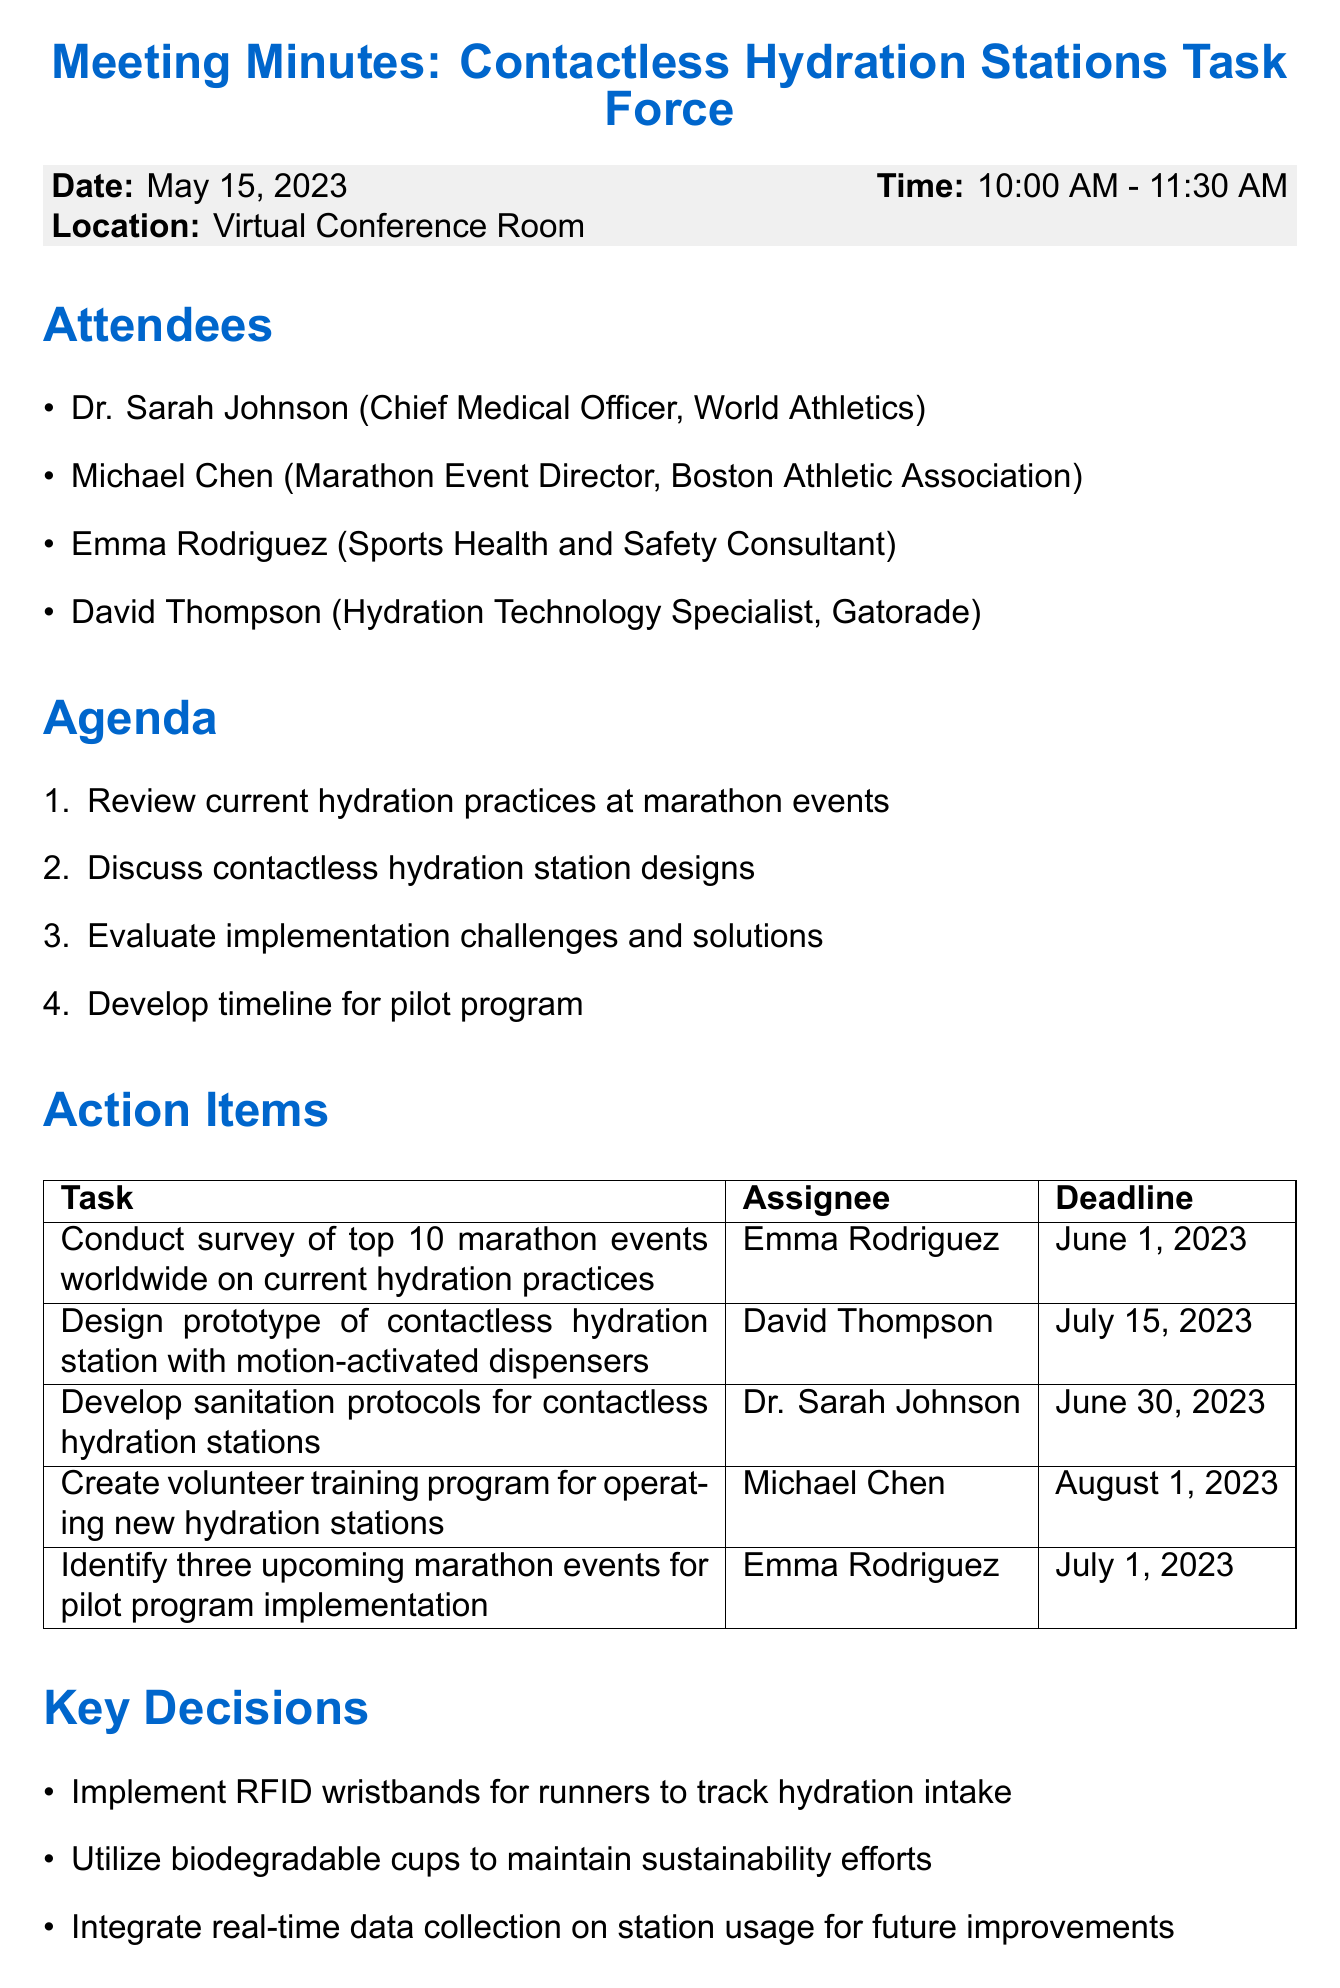What is the date of the meeting? The date of the meeting is mentioned in the document under meeting details.
Answer: May 15, 2023 Who is responsible for developing sanitation protocols? The document lists the assignee for each action item, with Dr. Sarah Johnson assigned to develop sanitation protocols.
Answer: Dr. Sarah Johnson What is the deadline for designing the prototype of the hydration station? The deadline for this task is specified in the action items section.
Answer: July 15, 2023 How many attendees were present at the meeting? The number of attendees can be counted from the list provided in the attendees section.
Answer: Four What key decision was made regarding the hydration intake? The key decisions section includes several decisions made during the meeting, one specifies using RFID wristbands to track hydration intake.
Answer: Implement RFID wristbands What is included in the agenda for the next meeting? The agenda for the next meeting is provided in the next meeting section of the document.
Answer: Review prototype design and finalize pilot program details Which action item has the earliest deadline? By reviewing the deadlines listed for each action item, the earliest can be identified.
Answer: June 1, 2023 What is the location of the meeting? The location is stated in the meeting details section of the document.
Answer: Virtual Conference Room Who is tasked with creating the volunteer training program? The assignee for this task is listed in the action items section.
Answer: Michael Chen 